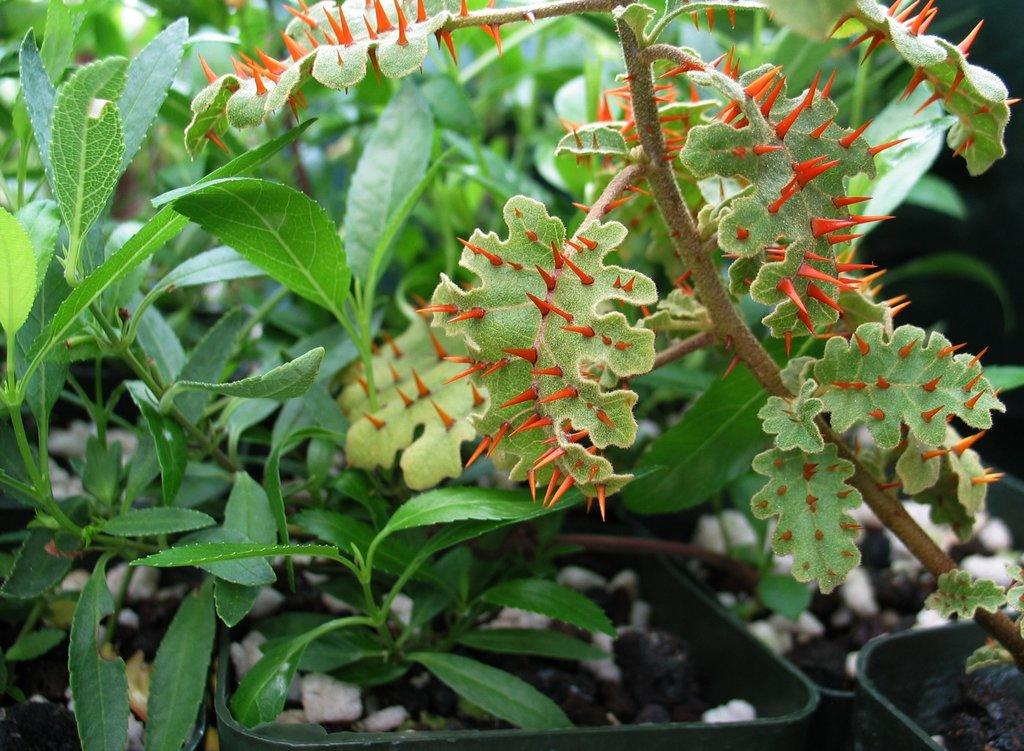What type of living organisms can be seen in the image? Plants can be seen in the image. Where are the plants located? The plants are on the land. Can you describe any specific features of the plants in the image? One of the plants has orange thrones. What type of club can be seen in the image? There is no club present in the image; it features plants on the land. Are there any pests visible on the plants in the image? There is no indication of pests on the plants in the image. 